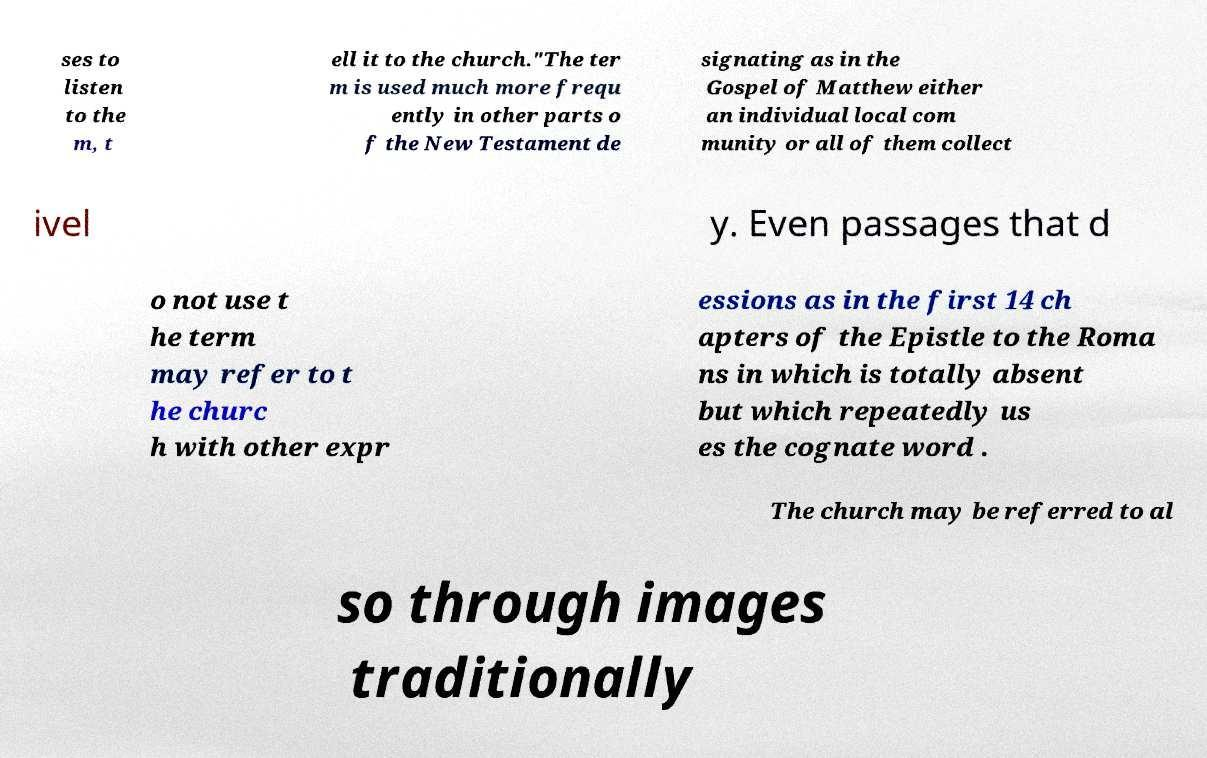Please read and relay the text visible in this image. What does it say? ses to listen to the m, t ell it to the church."The ter m is used much more frequ ently in other parts o f the New Testament de signating as in the Gospel of Matthew either an individual local com munity or all of them collect ivel y. Even passages that d o not use t he term may refer to t he churc h with other expr essions as in the first 14 ch apters of the Epistle to the Roma ns in which is totally absent but which repeatedly us es the cognate word . The church may be referred to al so through images traditionally 